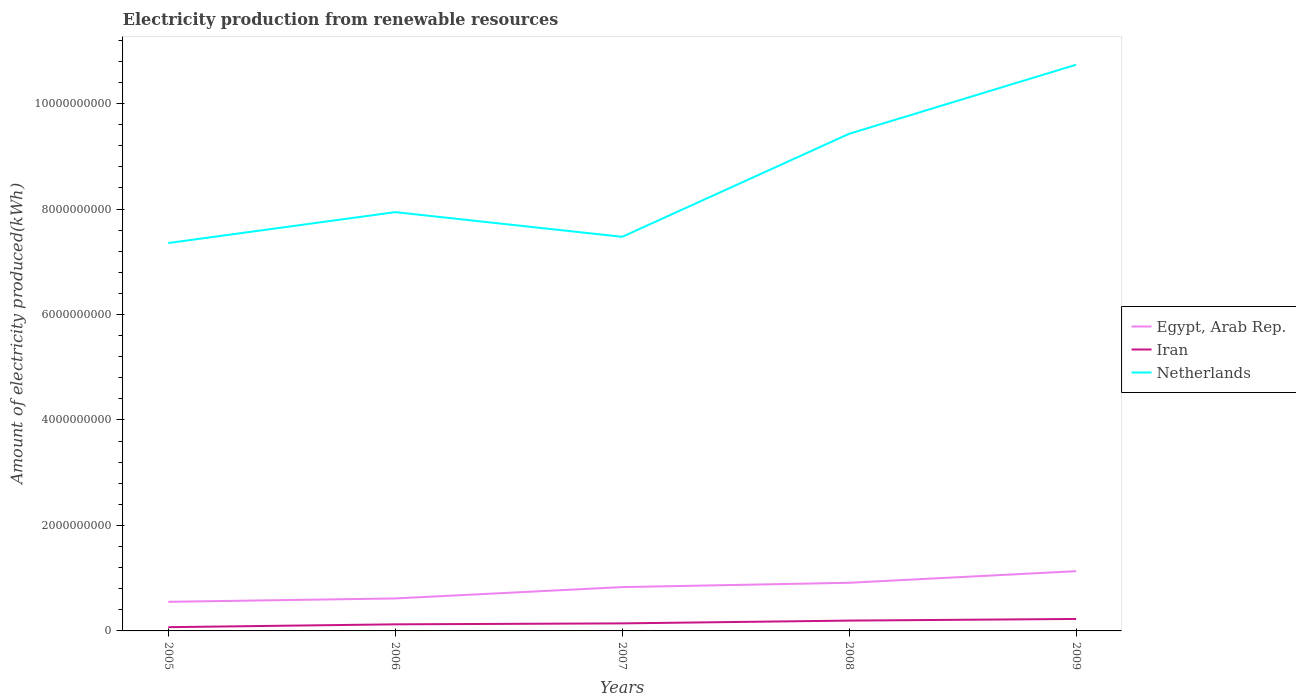Across all years, what is the maximum amount of electricity produced in Iran?
Offer a very short reply. 7.10e+07. In which year was the amount of electricity produced in Netherlands maximum?
Provide a succinct answer. 2005. What is the total amount of electricity produced in Egypt, Arab Rep. in the graph?
Your response must be concise. -5.17e+08. What is the difference between the highest and the second highest amount of electricity produced in Netherlands?
Offer a very short reply. 3.38e+09. What is the difference between the highest and the lowest amount of electricity produced in Netherlands?
Your response must be concise. 2. How many years are there in the graph?
Offer a very short reply. 5. Are the values on the major ticks of Y-axis written in scientific E-notation?
Your response must be concise. No. Does the graph contain grids?
Provide a short and direct response. No. How are the legend labels stacked?
Provide a succinct answer. Vertical. What is the title of the graph?
Your answer should be very brief. Electricity production from renewable resources. What is the label or title of the X-axis?
Ensure brevity in your answer.  Years. What is the label or title of the Y-axis?
Your response must be concise. Amount of electricity produced(kWh). What is the Amount of electricity produced(kWh) in Egypt, Arab Rep. in 2005?
Provide a succinct answer. 5.52e+08. What is the Amount of electricity produced(kWh) of Iran in 2005?
Your answer should be compact. 7.10e+07. What is the Amount of electricity produced(kWh) in Netherlands in 2005?
Keep it short and to the point. 7.36e+09. What is the Amount of electricity produced(kWh) of Egypt, Arab Rep. in 2006?
Give a very brief answer. 6.16e+08. What is the Amount of electricity produced(kWh) in Iran in 2006?
Your answer should be compact. 1.25e+08. What is the Amount of electricity produced(kWh) of Netherlands in 2006?
Keep it short and to the point. 7.94e+09. What is the Amount of electricity produced(kWh) in Egypt, Arab Rep. in 2007?
Provide a short and direct response. 8.31e+08. What is the Amount of electricity produced(kWh) in Iran in 2007?
Your answer should be very brief. 1.43e+08. What is the Amount of electricity produced(kWh) of Netherlands in 2007?
Make the answer very short. 7.47e+09. What is the Amount of electricity produced(kWh) in Egypt, Arab Rep. in 2008?
Your answer should be compact. 9.13e+08. What is the Amount of electricity produced(kWh) of Iran in 2008?
Your answer should be compact. 1.96e+08. What is the Amount of electricity produced(kWh) in Netherlands in 2008?
Offer a very short reply. 9.43e+09. What is the Amount of electricity produced(kWh) of Egypt, Arab Rep. in 2009?
Your answer should be compact. 1.13e+09. What is the Amount of electricity produced(kWh) in Iran in 2009?
Make the answer very short. 2.27e+08. What is the Amount of electricity produced(kWh) of Netherlands in 2009?
Make the answer very short. 1.07e+1. Across all years, what is the maximum Amount of electricity produced(kWh) of Egypt, Arab Rep.?
Provide a short and direct response. 1.13e+09. Across all years, what is the maximum Amount of electricity produced(kWh) in Iran?
Keep it short and to the point. 2.27e+08. Across all years, what is the maximum Amount of electricity produced(kWh) in Netherlands?
Give a very brief answer. 1.07e+1. Across all years, what is the minimum Amount of electricity produced(kWh) in Egypt, Arab Rep.?
Your answer should be compact. 5.52e+08. Across all years, what is the minimum Amount of electricity produced(kWh) in Iran?
Provide a short and direct response. 7.10e+07. Across all years, what is the minimum Amount of electricity produced(kWh) of Netherlands?
Ensure brevity in your answer.  7.36e+09. What is the total Amount of electricity produced(kWh) in Egypt, Arab Rep. in the graph?
Offer a terse response. 4.04e+09. What is the total Amount of electricity produced(kWh) in Iran in the graph?
Ensure brevity in your answer.  7.62e+08. What is the total Amount of electricity produced(kWh) in Netherlands in the graph?
Your response must be concise. 4.29e+1. What is the difference between the Amount of electricity produced(kWh) of Egypt, Arab Rep. in 2005 and that in 2006?
Your answer should be compact. -6.40e+07. What is the difference between the Amount of electricity produced(kWh) of Iran in 2005 and that in 2006?
Make the answer very short. -5.40e+07. What is the difference between the Amount of electricity produced(kWh) of Netherlands in 2005 and that in 2006?
Your answer should be very brief. -5.86e+08. What is the difference between the Amount of electricity produced(kWh) in Egypt, Arab Rep. in 2005 and that in 2007?
Your response must be concise. -2.79e+08. What is the difference between the Amount of electricity produced(kWh) of Iran in 2005 and that in 2007?
Provide a succinct answer. -7.20e+07. What is the difference between the Amount of electricity produced(kWh) of Netherlands in 2005 and that in 2007?
Your answer should be compact. -1.18e+08. What is the difference between the Amount of electricity produced(kWh) in Egypt, Arab Rep. in 2005 and that in 2008?
Give a very brief answer. -3.61e+08. What is the difference between the Amount of electricity produced(kWh) in Iran in 2005 and that in 2008?
Offer a very short reply. -1.25e+08. What is the difference between the Amount of electricity produced(kWh) in Netherlands in 2005 and that in 2008?
Offer a very short reply. -2.07e+09. What is the difference between the Amount of electricity produced(kWh) of Egypt, Arab Rep. in 2005 and that in 2009?
Provide a short and direct response. -5.81e+08. What is the difference between the Amount of electricity produced(kWh) in Iran in 2005 and that in 2009?
Provide a short and direct response. -1.56e+08. What is the difference between the Amount of electricity produced(kWh) of Netherlands in 2005 and that in 2009?
Your answer should be compact. -3.38e+09. What is the difference between the Amount of electricity produced(kWh) of Egypt, Arab Rep. in 2006 and that in 2007?
Give a very brief answer. -2.15e+08. What is the difference between the Amount of electricity produced(kWh) of Iran in 2006 and that in 2007?
Provide a short and direct response. -1.80e+07. What is the difference between the Amount of electricity produced(kWh) of Netherlands in 2006 and that in 2007?
Your response must be concise. 4.68e+08. What is the difference between the Amount of electricity produced(kWh) in Egypt, Arab Rep. in 2006 and that in 2008?
Keep it short and to the point. -2.97e+08. What is the difference between the Amount of electricity produced(kWh) in Iran in 2006 and that in 2008?
Your response must be concise. -7.10e+07. What is the difference between the Amount of electricity produced(kWh) of Netherlands in 2006 and that in 2008?
Give a very brief answer. -1.49e+09. What is the difference between the Amount of electricity produced(kWh) in Egypt, Arab Rep. in 2006 and that in 2009?
Your answer should be compact. -5.17e+08. What is the difference between the Amount of electricity produced(kWh) of Iran in 2006 and that in 2009?
Provide a succinct answer. -1.02e+08. What is the difference between the Amount of electricity produced(kWh) of Netherlands in 2006 and that in 2009?
Your answer should be compact. -2.80e+09. What is the difference between the Amount of electricity produced(kWh) in Egypt, Arab Rep. in 2007 and that in 2008?
Give a very brief answer. -8.20e+07. What is the difference between the Amount of electricity produced(kWh) in Iran in 2007 and that in 2008?
Provide a short and direct response. -5.30e+07. What is the difference between the Amount of electricity produced(kWh) of Netherlands in 2007 and that in 2008?
Offer a very short reply. -1.95e+09. What is the difference between the Amount of electricity produced(kWh) of Egypt, Arab Rep. in 2007 and that in 2009?
Your response must be concise. -3.02e+08. What is the difference between the Amount of electricity produced(kWh) of Iran in 2007 and that in 2009?
Ensure brevity in your answer.  -8.40e+07. What is the difference between the Amount of electricity produced(kWh) in Netherlands in 2007 and that in 2009?
Your response must be concise. -3.26e+09. What is the difference between the Amount of electricity produced(kWh) of Egypt, Arab Rep. in 2008 and that in 2009?
Make the answer very short. -2.20e+08. What is the difference between the Amount of electricity produced(kWh) of Iran in 2008 and that in 2009?
Offer a terse response. -3.10e+07. What is the difference between the Amount of electricity produced(kWh) of Netherlands in 2008 and that in 2009?
Give a very brief answer. -1.31e+09. What is the difference between the Amount of electricity produced(kWh) in Egypt, Arab Rep. in 2005 and the Amount of electricity produced(kWh) in Iran in 2006?
Offer a very short reply. 4.27e+08. What is the difference between the Amount of electricity produced(kWh) in Egypt, Arab Rep. in 2005 and the Amount of electricity produced(kWh) in Netherlands in 2006?
Keep it short and to the point. -7.39e+09. What is the difference between the Amount of electricity produced(kWh) in Iran in 2005 and the Amount of electricity produced(kWh) in Netherlands in 2006?
Make the answer very short. -7.87e+09. What is the difference between the Amount of electricity produced(kWh) in Egypt, Arab Rep. in 2005 and the Amount of electricity produced(kWh) in Iran in 2007?
Provide a succinct answer. 4.09e+08. What is the difference between the Amount of electricity produced(kWh) of Egypt, Arab Rep. in 2005 and the Amount of electricity produced(kWh) of Netherlands in 2007?
Provide a succinct answer. -6.92e+09. What is the difference between the Amount of electricity produced(kWh) in Iran in 2005 and the Amount of electricity produced(kWh) in Netherlands in 2007?
Your response must be concise. -7.40e+09. What is the difference between the Amount of electricity produced(kWh) of Egypt, Arab Rep. in 2005 and the Amount of electricity produced(kWh) of Iran in 2008?
Keep it short and to the point. 3.56e+08. What is the difference between the Amount of electricity produced(kWh) of Egypt, Arab Rep. in 2005 and the Amount of electricity produced(kWh) of Netherlands in 2008?
Offer a terse response. -8.88e+09. What is the difference between the Amount of electricity produced(kWh) of Iran in 2005 and the Amount of electricity produced(kWh) of Netherlands in 2008?
Offer a terse response. -9.36e+09. What is the difference between the Amount of electricity produced(kWh) in Egypt, Arab Rep. in 2005 and the Amount of electricity produced(kWh) in Iran in 2009?
Your response must be concise. 3.25e+08. What is the difference between the Amount of electricity produced(kWh) of Egypt, Arab Rep. in 2005 and the Amount of electricity produced(kWh) of Netherlands in 2009?
Keep it short and to the point. -1.02e+1. What is the difference between the Amount of electricity produced(kWh) in Iran in 2005 and the Amount of electricity produced(kWh) in Netherlands in 2009?
Your response must be concise. -1.07e+1. What is the difference between the Amount of electricity produced(kWh) of Egypt, Arab Rep. in 2006 and the Amount of electricity produced(kWh) of Iran in 2007?
Offer a terse response. 4.73e+08. What is the difference between the Amount of electricity produced(kWh) of Egypt, Arab Rep. in 2006 and the Amount of electricity produced(kWh) of Netherlands in 2007?
Ensure brevity in your answer.  -6.86e+09. What is the difference between the Amount of electricity produced(kWh) in Iran in 2006 and the Amount of electricity produced(kWh) in Netherlands in 2007?
Offer a very short reply. -7.35e+09. What is the difference between the Amount of electricity produced(kWh) of Egypt, Arab Rep. in 2006 and the Amount of electricity produced(kWh) of Iran in 2008?
Ensure brevity in your answer.  4.20e+08. What is the difference between the Amount of electricity produced(kWh) of Egypt, Arab Rep. in 2006 and the Amount of electricity produced(kWh) of Netherlands in 2008?
Your answer should be compact. -8.81e+09. What is the difference between the Amount of electricity produced(kWh) in Iran in 2006 and the Amount of electricity produced(kWh) in Netherlands in 2008?
Ensure brevity in your answer.  -9.30e+09. What is the difference between the Amount of electricity produced(kWh) in Egypt, Arab Rep. in 2006 and the Amount of electricity produced(kWh) in Iran in 2009?
Keep it short and to the point. 3.89e+08. What is the difference between the Amount of electricity produced(kWh) in Egypt, Arab Rep. in 2006 and the Amount of electricity produced(kWh) in Netherlands in 2009?
Offer a very short reply. -1.01e+1. What is the difference between the Amount of electricity produced(kWh) in Iran in 2006 and the Amount of electricity produced(kWh) in Netherlands in 2009?
Provide a succinct answer. -1.06e+1. What is the difference between the Amount of electricity produced(kWh) of Egypt, Arab Rep. in 2007 and the Amount of electricity produced(kWh) of Iran in 2008?
Provide a succinct answer. 6.35e+08. What is the difference between the Amount of electricity produced(kWh) in Egypt, Arab Rep. in 2007 and the Amount of electricity produced(kWh) in Netherlands in 2008?
Provide a short and direct response. -8.60e+09. What is the difference between the Amount of electricity produced(kWh) of Iran in 2007 and the Amount of electricity produced(kWh) of Netherlands in 2008?
Ensure brevity in your answer.  -9.28e+09. What is the difference between the Amount of electricity produced(kWh) of Egypt, Arab Rep. in 2007 and the Amount of electricity produced(kWh) of Iran in 2009?
Ensure brevity in your answer.  6.04e+08. What is the difference between the Amount of electricity produced(kWh) of Egypt, Arab Rep. in 2007 and the Amount of electricity produced(kWh) of Netherlands in 2009?
Make the answer very short. -9.91e+09. What is the difference between the Amount of electricity produced(kWh) in Iran in 2007 and the Amount of electricity produced(kWh) in Netherlands in 2009?
Keep it short and to the point. -1.06e+1. What is the difference between the Amount of electricity produced(kWh) in Egypt, Arab Rep. in 2008 and the Amount of electricity produced(kWh) in Iran in 2009?
Ensure brevity in your answer.  6.86e+08. What is the difference between the Amount of electricity produced(kWh) in Egypt, Arab Rep. in 2008 and the Amount of electricity produced(kWh) in Netherlands in 2009?
Your answer should be compact. -9.82e+09. What is the difference between the Amount of electricity produced(kWh) of Iran in 2008 and the Amount of electricity produced(kWh) of Netherlands in 2009?
Ensure brevity in your answer.  -1.05e+1. What is the average Amount of electricity produced(kWh) in Egypt, Arab Rep. per year?
Your response must be concise. 8.09e+08. What is the average Amount of electricity produced(kWh) of Iran per year?
Provide a succinct answer. 1.52e+08. What is the average Amount of electricity produced(kWh) in Netherlands per year?
Make the answer very short. 8.59e+09. In the year 2005, what is the difference between the Amount of electricity produced(kWh) of Egypt, Arab Rep. and Amount of electricity produced(kWh) of Iran?
Provide a short and direct response. 4.81e+08. In the year 2005, what is the difference between the Amount of electricity produced(kWh) of Egypt, Arab Rep. and Amount of electricity produced(kWh) of Netherlands?
Provide a short and direct response. -6.80e+09. In the year 2005, what is the difference between the Amount of electricity produced(kWh) in Iran and Amount of electricity produced(kWh) in Netherlands?
Ensure brevity in your answer.  -7.28e+09. In the year 2006, what is the difference between the Amount of electricity produced(kWh) of Egypt, Arab Rep. and Amount of electricity produced(kWh) of Iran?
Offer a very short reply. 4.91e+08. In the year 2006, what is the difference between the Amount of electricity produced(kWh) of Egypt, Arab Rep. and Amount of electricity produced(kWh) of Netherlands?
Ensure brevity in your answer.  -7.33e+09. In the year 2006, what is the difference between the Amount of electricity produced(kWh) of Iran and Amount of electricity produced(kWh) of Netherlands?
Provide a succinct answer. -7.82e+09. In the year 2007, what is the difference between the Amount of electricity produced(kWh) of Egypt, Arab Rep. and Amount of electricity produced(kWh) of Iran?
Offer a very short reply. 6.88e+08. In the year 2007, what is the difference between the Amount of electricity produced(kWh) in Egypt, Arab Rep. and Amount of electricity produced(kWh) in Netherlands?
Give a very brief answer. -6.64e+09. In the year 2007, what is the difference between the Amount of electricity produced(kWh) of Iran and Amount of electricity produced(kWh) of Netherlands?
Provide a succinct answer. -7.33e+09. In the year 2008, what is the difference between the Amount of electricity produced(kWh) in Egypt, Arab Rep. and Amount of electricity produced(kWh) in Iran?
Offer a terse response. 7.17e+08. In the year 2008, what is the difference between the Amount of electricity produced(kWh) of Egypt, Arab Rep. and Amount of electricity produced(kWh) of Netherlands?
Offer a terse response. -8.52e+09. In the year 2008, what is the difference between the Amount of electricity produced(kWh) of Iran and Amount of electricity produced(kWh) of Netherlands?
Offer a terse response. -9.23e+09. In the year 2009, what is the difference between the Amount of electricity produced(kWh) of Egypt, Arab Rep. and Amount of electricity produced(kWh) of Iran?
Provide a short and direct response. 9.06e+08. In the year 2009, what is the difference between the Amount of electricity produced(kWh) of Egypt, Arab Rep. and Amount of electricity produced(kWh) of Netherlands?
Your answer should be compact. -9.60e+09. In the year 2009, what is the difference between the Amount of electricity produced(kWh) of Iran and Amount of electricity produced(kWh) of Netherlands?
Offer a terse response. -1.05e+1. What is the ratio of the Amount of electricity produced(kWh) of Egypt, Arab Rep. in 2005 to that in 2006?
Give a very brief answer. 0.9. What is the ratio of the Amount of electricity produced(kWh) in Iran in 2005 to that in 2006?
Your response must be concise. 0.57. What is the ratio of the Amount of electricity produced(kWh) in Netherlands in 2005 to that in 2006?
Your response must be concise. 0.93. What is the ratio of the Amount of electricity produced(kWh) of Egypt, Arab Rep. in 2005 to that in 2007?
Provide a succinct answer. 0.66. What is the ratio of the Amount of electricity produced(kWh) in Iran in 2005 to that in 2007?
Make the answer very short. 0.5. What is the ratio of the Amount of electricity produced(kWh) of Netherlands in 2005 to that in 2007?
Offer a very short reply. 0.98. What is the ratio of the Amount of electricity produced(kWh) in Egypt, Arab Rep. in 2005 to that in 2008?
Your response must be concise. 0.6. What is the ratio of the Amount of electricity produced(kWh) in Iran in 2005 to that in 2008?
Make the answer very short. 0.36. What is the ratio of the Amount of electricity produced(kWh) of Netherlands in 2005 to that in 2008?
Provide a succinct answer. 0.78. What is the ratio of the Amount of electricity produced(kWh) of Egypt, Arab Rep. in 2005 to that in 2009?
Ensure brevity in your answer.  0.49. What is the ratio of the Amount of electricity produced(kWh) of Iran in 2005 to that in 2009?
Provide a short and direct response. 0.31. What is the ratio of the Amount of electricity produced(kWh) in Netherlands in 2005 to that in 2009?
Your answer should be very brief. 0.69. What is the ratio of the Amount of electricity produced(kWh) of Egypt, Arab Rep. in 2006 to that in 2007?
Make the answer very short. 0.74. What is the ratio of the Amount of electricity produced(kWh) of Iran in 2006 to that in 2007?
Offer a very short reply. 0.87. What is the ratio of the Amount of electricity produced(kWh) in Netherlands in 2006 to that in 2007?
Make the answer very short. 1.06. What is the ratio of the Amount of electricity produced(kWh) of Egypt, Arab Rep. in 2006 to that in 2008?
Provide a succinct answer. 0.67. What is the ratio of the Amount of electricity produced(kWh) of Iran in 2006 to that in 2008?
Provide a succinct answer. 0.64. What is the ratio of the Amount of electricity produced(kWh) in Netherlands in 2006 to that in 2008?
Give a very brief answer. 0.84. What is the ratio of the Amount of electricity produced(kWh) of Egypt, Arab Rep. in 2006 to that in 2009?
Offer a terse response. 0.54. What is the ratio of the Amount of electricity produced(kWh) of Iran in 2006 to that in 2009?
Provide a short and direct response. 0.55. What is the ratio of the Amount of electricity produced(kWh) in Netherlands in 2006 to that in 2009?
Your answer should be very brief. 0.74. What is the ratio of the Amount of electricity produced(kWh) of Egypt, Arab Rep. in 2007 to that in 2008?
Offer a very short reply. 0.91. What is the ratio of the Amount of electricity produced(kWh) of Iran in 2007 to that in 2008?
Give a very brief answer. 0.73. What is the ratio of the Amount of electricity produced(kWh) of Netherlands in 2007 to that in 2008?
Your answer should be very brief. 0.79. What is the ratio of the Amount of electricity produced(kWh) in Egypt, Arab Rep. in 2007 to that in 2009?
Keep it short and to the point. 0.73. What is the ratio of the Amount of electricity produced(kWh) in Iran in 2007 to that in 2009?
Make the answer very short. 0.63. What is the ratio of the Amount of electricity produced(kWh) of Netherlands in 2007 to that in 2009?
Offer a terse response. 0.7. What is the ratio of the Amount of electricity produced(kWh) in Egypt, Arab Rep. in 2008 to that in 2009?
Make the answer very short. 0.81. What is the ratio of the Amount of electricity produced(kWh) of Iran in 2008 to that in 2009?
Offer a very short reply. 0.86. What is the ratio of the Amount of electricity produced(kWh) in Netherlands in 2008 to that in 2009?
Make the answer very short. 0.88. What is the difference between the highest and the second highest Amount of electricity produced(kWh) in Egypt, Arab Rep.?
Give a very brief answer. 2.20e+08. What is the difference between the highest and the second highest Amount of electricity produced(kWh) of Iran?
Your answer should be compact. 3.10e+07. What is the difference between the highest and the second highest Amount of electricity produced(kWh) in Netherlands?
Make the answer very short. 1.31e+09. What is the difference between the highest and the lowest Amount of electricity produced(kWh) in Egypt, Arab Rep.?
Give a very brief answer. 5.81e+08. What is the difference between the highest and the lowest Amount of electricity produced(kWh) of Iran?
Provide a short and direct response. 1.56e+08. What is the difference between the highest and the lowest Amount of electricity produced(kWh) in Netherlands?
Provide a short and direct response. 3.38e+09. 